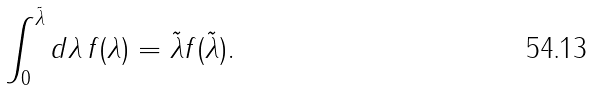Convert formula to latex. <formula><loc_0><loc_0><loc_500><loc_500>\int _ { 0 } ^ { \tilde { \lambda } } d \lambda \, f ( \lambda ) = \tilde { \lambda } f ( \tilde { \lambda } ) .</formula> 